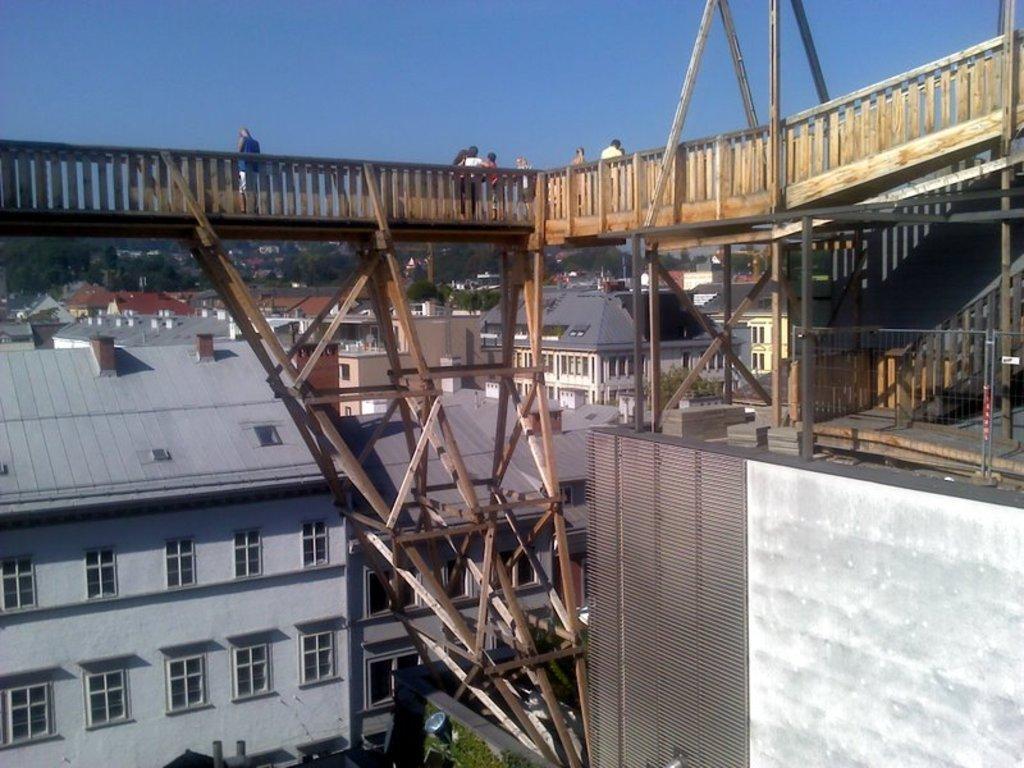In one or two sentences, can you explain what this image depicts? In this image, we can see wooden railing, few people, wooden poles, fencing. Background we can see so many buildings, trees, windows, walls and sky. 